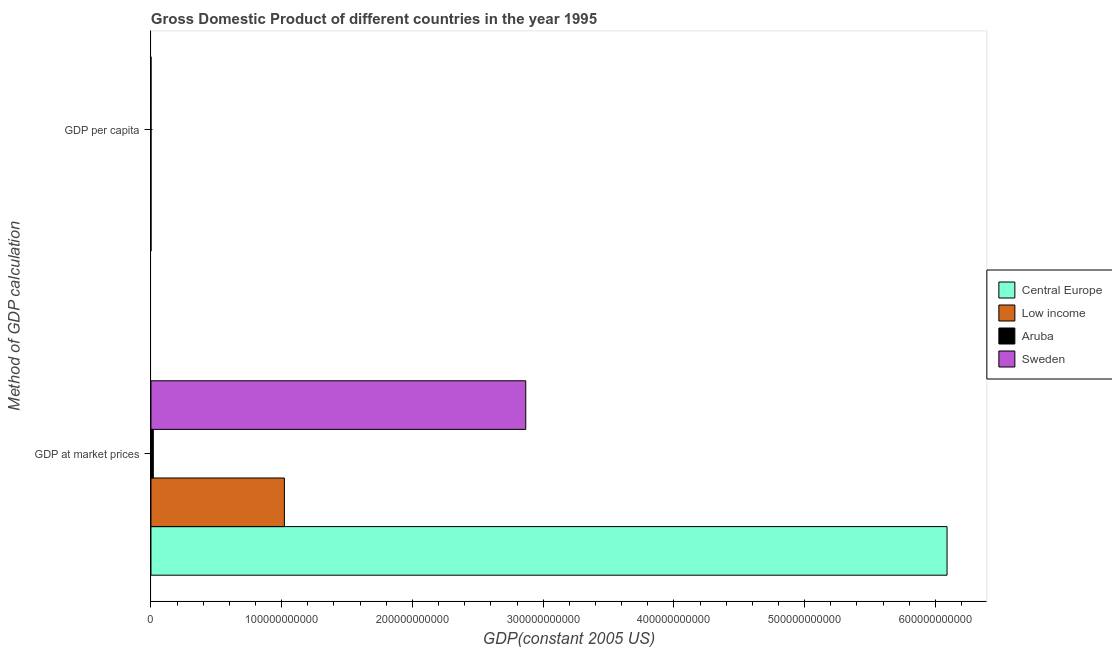Are the number of bars on each tick of the Y-axis equal?
Give a very brief answer. Yes. How many bars are there on the 2nd tick from the bottom?
Make the answer very short. 4. What is the label of the 2nd group of bars from the top?
Your answer should be very brief. GDP at market prices. What is the gdp per capita in Aruba?
Provide a succinct answer. 2.23e+04. Across all countries, what is the maximum gdp per capita?
Give a very brief answer. 3.25e+04. Across all countries, what is the minimum gdp at market prices?
Make the answer very short. 1.79e+09. In which country was the gdp per capita maximum?
Your answer should be compact. Sweden. In which country was the gdp at market prices minimum?
Offer a very short reply. Aruba. What is the total gdp at market prices in the graph?
Offer a very short reply. 9.99e+11. What is the difference between the gdp at market prices in Low income and that in Central Europe?
Your answer should be compact. -5.07e+11. What is the difference between the gdp at market prices in Central Europe and the gdp per capita in Aruba?
Your answer should be compact. 6.09e+11. What is the average gdp at market prices per country?
Keep it short and to the point. 2.50e+11. What is the difference between the gdp at market prices and gdp per capita in Sweden?
Your answer should be compact. 2.87e+11. What is the ratio of the gdp per capita in Central Europe to that in Aruba?
Offer a very short reply. 0.25. Is the gdp per capita in Aruba less than that in Low income?
Your response must be concise. No. In how many countries, is the gdp at market prices greater than the average gdp at market prices taken over all countries?
Make the answer very short. 2. What does the 3rd bar from the top in GDP at market prices represents?
Offer a very short reply. Low income. What does the 3rd bar from the bottom in GDP at market prices represents?
Provide a succinct answer. Aruba. How many bars are there?
Provide a succinct answer. 8. Are all the bars in the graph horizontal?
Ensure brevity in your answer.  Yes. How many countries are there in the graph?
Give a very brief answer. 4. What is the difference between two consecutive major ticks on the X-axis?
Ensure brevity in your answer.  1.00e+11. Does the graph contain any zero values?
Your response must be concise. No. Where does the legend appear in the graph?
Keep it short and to the point. Center right. What is the title of the graph?
Offer a terse response. Gross Domestic Product of different countries in the year 1995. Does "Central Europe" appear as one of the legend labels in the graph?
Provide a short and direct response. Yes. What is the label or title of the X-axis?
Your response must be concise. GDP(constant 2005 US). What is the label or title of the Y-axis?
Provide a short and direct response. Method of GDP calculation. What is the GDP(constant 2005 US) of Central Europe in GDP at market prices?
Your answer should be very brief. 6.09e+11. What is the GDP(constant 2005 US) in Low income in GDP at market prices?
Offer a terse response. 1.02e+11. What is the GDP(constant 2005 US) of Aruba in GDP at market prices?
Ensure brevity in your answer.  1.79e+09. What is the GDP(constant 2005 US) in Sweden in GDP at market prices?
Provide a succinct answer. 2.87e+11. What is the GDP(constant 2005 US) in Central Europe in GDP per capita?
Your response must be concise. 5540.08. What is the GDP(constant 2005 US) in Low income in GDP per capita?
Provide a short and direct response. 274.1. What is the GDP(constant 2005 US) of Aruba in GDP per capita?
Your response must be concise. 2.23e+04. What is the GDP(constant 2005 US) in Sweden in GDP per capita?
Make the answer very short. 3.25e+04. Across all Method of GDP calculation, what is the maximum GDP(constant 2005 US) of Central Europe?
Offer a very short reply. 6.09e+11. Across all Method of GDP calculation, what is the maximum GDP(constant 2005 US) in Low income?
Your answer should be compact. 1.02e+11. Across all Method of GDP calculation, what is the maximum GDP(constant 2005 US) of Aruba?
Offer a very short reply. 1.79e+09. Across all Method of GDP calculation, what is the maximum GDP(constant 2005 US) in Sweden?
Your answer should be compact. 2.87e+11. Across all Method of GDP calculation, what is the minimum GDP(constant 2005 US) of Central Europe?
Make the answer very short. 5540.08. Across all Method of GDP calculation, what is the minimum GDP(constant 2005 US) of Low income?
Your response must be concise. 274.1. Across all Method of GDP calculation, what is the minimum GDP(constant 2005 US) in Aruba?
Your response must be concise. 2.23e+04. Across all Method of GDP calculation, what is the minimum GDP(constant 2005 US) of Sweden?
Give a very brief answer. 3.25e+04. What is the total GDP(constant 2005 US) of Central Europe in the graph?
Provide a short and direct response. 6.09e+11. What is the total GDP(constant 2005 US) in Low income in the graph?
Make the answer very short. 1.02e+11. What is the total GDP(constant 2005 US) of Aruba in the graph?
Your response must be concise. 1.79e+09. What is the total GDP(constant 2005 US) in Sweden in the graph?
Provide a succinct answer. 2.87e+11. What is the difference between the GDP(constant 2005 US) of Central Europe in GDP at market prices and that in GDP per capita?
Keep it short and to the point. 6.09e+11. What is the difference between the GDP(constant 2005 US) of Low income in GDP at market prices and that in GDP per capita?
Offer a terse response. 1.02e+11. What is the difference between the GDP(constant 2005 US) of Aruba in GDP at market prices and that in GDP per capita?
Your answer should be very brief. 1.79e+09. What is the difference between the GDP(constant 2005 US) of Sweden in GDP at market prices and that in GDP per capita?
Keep it short and to the point. 2.87e+11. What is the difference between the GDP(constant 2005 US) of Central Europe in GDP at market prices and the GDP(constant 2005 US) of Low income in GDP per capita?
Give a very brief answer. 6.09e+11. What is the difference between the GDP(constant 2005 US) in Central Europe in GDP at market prices and the GDP(constant 2005 US) in Aruba in GDP per capita?
Offer a terse response. 6.09e+11. What is the difference between the GDP(constant 2005 US) of Central Europe in GDP at market prices and the GDP(constant 2005 US) of Sweden in GDP per capita?
Keep it short and to the point. 6.09e+11. What is the difference between the GDP(constant 2005 US) in Low income in GDP at market prices and the GDP(constant 2005 US) in Aruba in GDP per capita?
Give a very brief answer. 1.02e+11. What is the difference between the GDP(constant 2005 US) in Low income in GDP at market prices and the GDP(constant 2005 US) in Sweden in GDP per capita?
Keep it short and to the point. 1.02e+11. What is the difference between the GDP(constant 2005 US) of Aruba in GDP at market prices and the GDP(constant 2005 US) of Sweden in GDP per capita?
Offer a very short reply. 1.79e+09. What is the average GDP(constant 2005 US) in Central Europe per Method of GDP calculation?
Your response must be concise. 3.04e+11. What is the average GDP(constant 2005 US) of Low income per Method of GDP calculation?
Offer a very short reply. 5.10e+1. What is the average GDP(constant 2005 US) of Aruba per Method of GDP calculation?
Offer a very short reply. 8.96e+08. What is the average GDP(constant 2005 US) in Sweden per Method of GDP calculation?
Your answer should be very brief. 1.43e+11. What is the difference between the GDP(constant 2005 US) of Central Europe and GDP(constant 2005 US) of Low income in GDP at market prices?
Make the answer very short. 5.07e+11. What is the difference between the GDP(constant 2005 US) of Central Europe and GDP(constant 2005 US) of Aruba in GDP at market prices?
Provide a succinct answer. 6.07e+11. What is the difference between the GDP(constant 2005 US) in Central Europe and GDP(constant 2005 US) in Sweden in GDP at market prices?
Make the answer very short. 3.22e+11. What is the difference between the GDP(constant 2005 US) in Low income and GDP(constant 2005 US) in Aruba in GDP at market prices?
Your response must be concise. 1.00e+11. What is the difference between the GDP(constant 2005 US) in Low income and GDP(constant 2005 US) in Sweden in GDP at market prices?
Offer a terse response. -1.85e+11. What is the difference between the GDP(constant 2005 US) of Aruba and GDP(constant 2005 US) of Sweden in GDP at market prices?
Your answer should be compact. -2.85e+11. What is the difference between the GDP(constant 2005 US) in Central Europe and GDP(constant 2005 US) in Low income in GDP per capita?
Offer a terse response. 5265.98. What is the difference between the GDP(constant 2005 US) of Central Europe and GDP(constant 2005 US) of Aruba in GDP per capita?
Give a very brief answer. -1.68e+04. What is the difference between the GDP(constant 2005 US) in Central Europe and GDP(constant 2005 US) in Sweden in GDP per capita?
Offer a very short reply. -2.69e+04. What is the difference between the GDP(constant 2005 US) of Low income and GDP(constant 2005 US) of Aruba in GDP per capita?
Keep it short and to the point. -2.20e+04. What is the difference between the GDP(constant 2005 US) of Low income and GDP(constant 2005 US) of Sweden in GDP per capita?
Offer a very short reply. -3.22e+04. What is the difference between the GDP(constant 2005 US) in Aruba and GDP(constant 2005 US) in Sweden in GDP per capita?
Offer a very short reply. -1.02e+04. What is the ratio of the GDP(constant 2005 US) in Central Europe in GDP at market prices to that in GDP per capita?
Keep it short and to the point. 1.10e+08. What is the ratio of the GDP(constant 2005 US) of Low income in GDP at market prices to that in GDP per capita?
Your answer should be compact. 3.72e+08. What is the ratio of the GDP(constant 2005 US) in Aruba in GDP at market prices to that in GDP per capita?
Your answer should be compact. 8.03e+04. What is the ratio of the GDP(constant 2005 US) of Sweden in GDP at market prices to that in GDP per capita?
Your answer should be very brief. 8.83e+06. What is the difference between the highest and the second highest GDP(constant 2005 US) of Central Europe?
Offer a very short reply. 6.09e+11. What is the difference between the highest and the second highest GDP(constant 2005 US) of Low income?
Provide a short and direct response. 1.02e+11. What is the difference between the highest and the second highest GDP(constant 2005 US) of Aruba?
Provide a succinct answer. 1.79e+09. What is the difference between the highest and the second highest GDP(constant 2005 US) in Sweden?
Ensure brevity in your answer.  2.87e+11. What is the difference between the highest and the lowest GDP(constant 2005 US) of Central Europe?
Your answer should be compact. 6.09e+11. What is the difference between the highest and the lowest GDP(constant 2005 US) of Low income?
Your response must be concise. 1.02e+11. What is the difference between the highest and the lowest GDP(constant 2005 US) of Aruba?
Offer a very short reply. 1.79e+09. What is the difference between the highest and the lowest GDP(constant 2005 US) of Sweden?
Offer a terse response. 2.87e+11. 